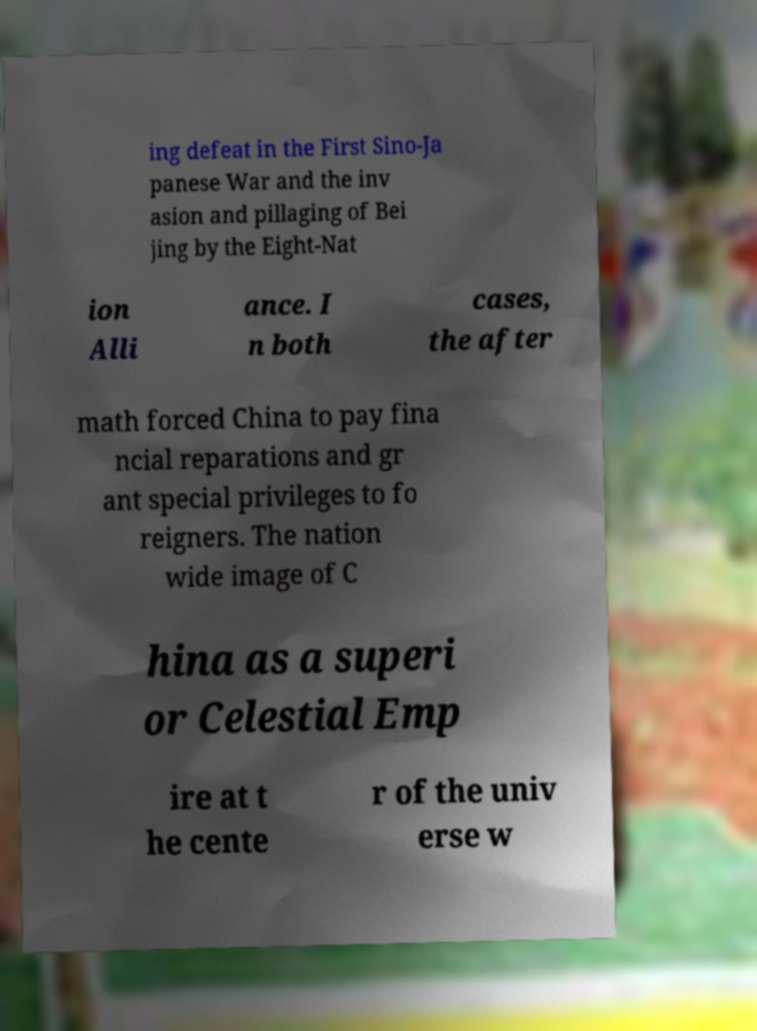Could you assist in decoding the text presented in this image and type it out clearly? ing defeat in the First Sino-Ja panese War and the inv asion and pillaging of Bei jing by the Eight-Nat ion Alli ance. I n both cases, the after math forced China to pay fina ncial reparations and gr ant special privileges to fo reigners. The nation wide image of C hina as a superi or Celestial Emp ire at t he cente r of the univ erse w 